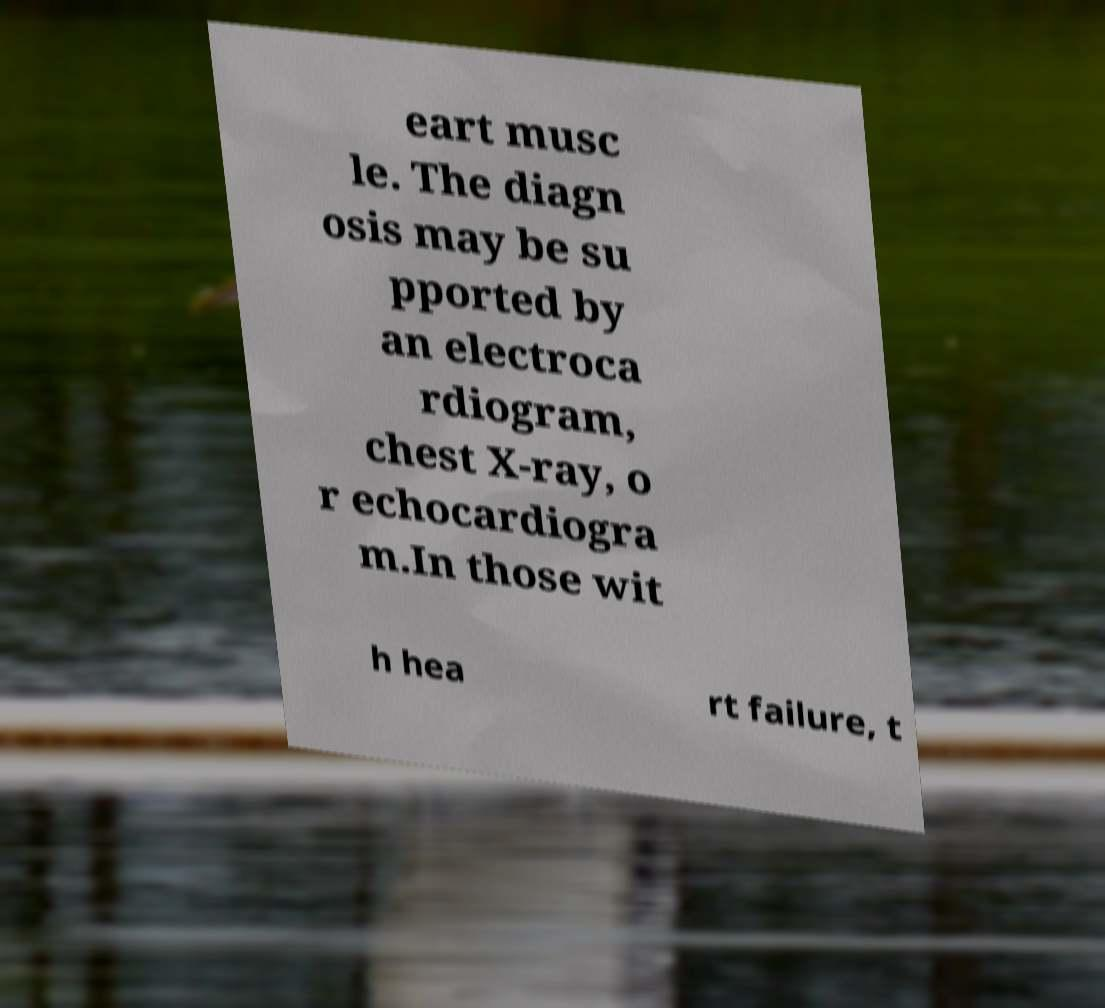I need the written content from this picture converted into text. Can you do that? eart musc le. The diagn osis may be su pported by an electroca rdiogram, chest X-ray, o r echocardiogra m.In those wit h hea rt failure, t 